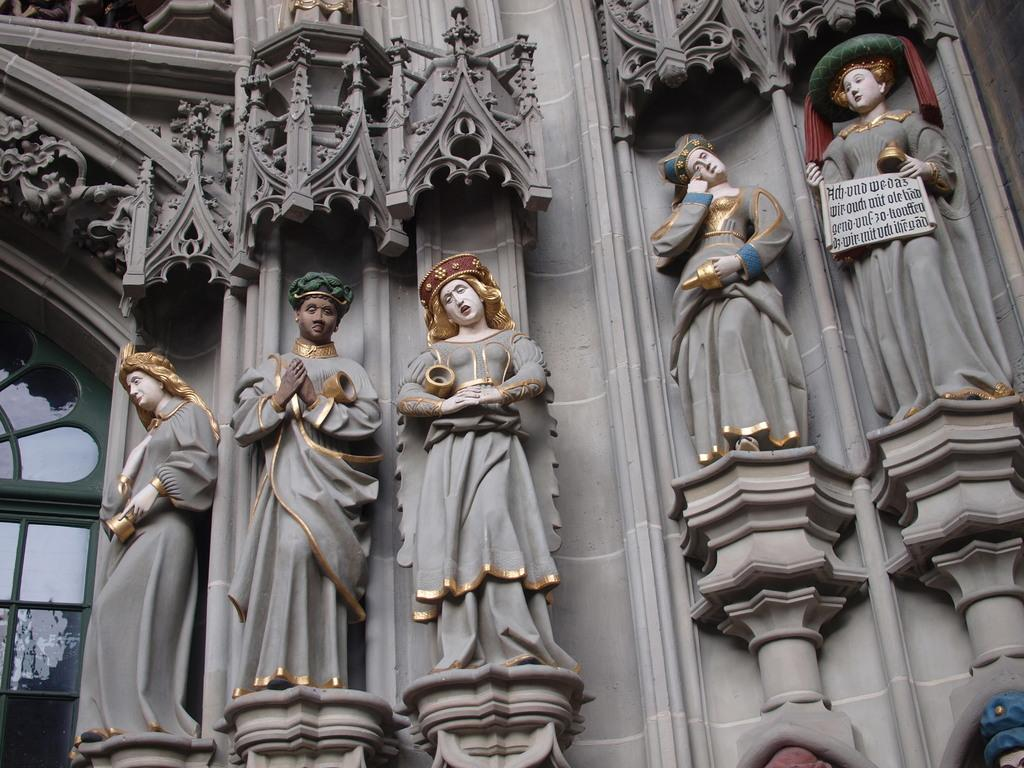What type of structure is present in the image? There is a building in the image. What artistic features can be seen on the building? The building has sculptures and carvings. What type of leaf is falling from the back of the building in the image? There is no leaf present in the image, and the back of the building is not mentioned. 